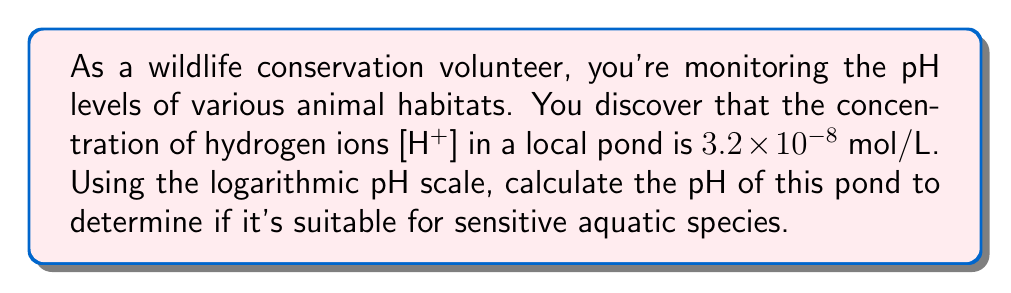Help me with this question. To solve this problem, we'll use the logarithmic pH scale formula:

$$ \text{pH} = -\log_{10}[\text{H}^+] $$

Given:
$[\text{H}^+] = 3.2 \times 10^{-8}$ mol/L

Step 1: Insert the given hydrogen ion concentration into the pH formula.
$$ \text{pH} = -\log_{10}(3.2 \times 10^{-8}) $$

Step 2: Use the logarithm property $\log(a \times 10^n) = \log(a) + n$ to simplify:
$$ \text{pH} = -(\log_{10}(3.2) + \log_{10}(10^{-8})) $$
$$ \text{pH} = -(\log_{10}(3.2) - 8) $$

Step 3: Calculate $\log_{10}(3.2)$ using a calculator:
$$ \text{pH} = -(0.5051 - 8) $$

Step 4: Simplify:
$$ \text{pH} = -0.5051 + 8 = 7.4949 $$

Step 5: Round to two decimal places:
$$ \text{pH} = 7.49 $$

This pH level is close to neutral (pH 7), which is generally suitable for many aquatic species.
Answer: 7.49 